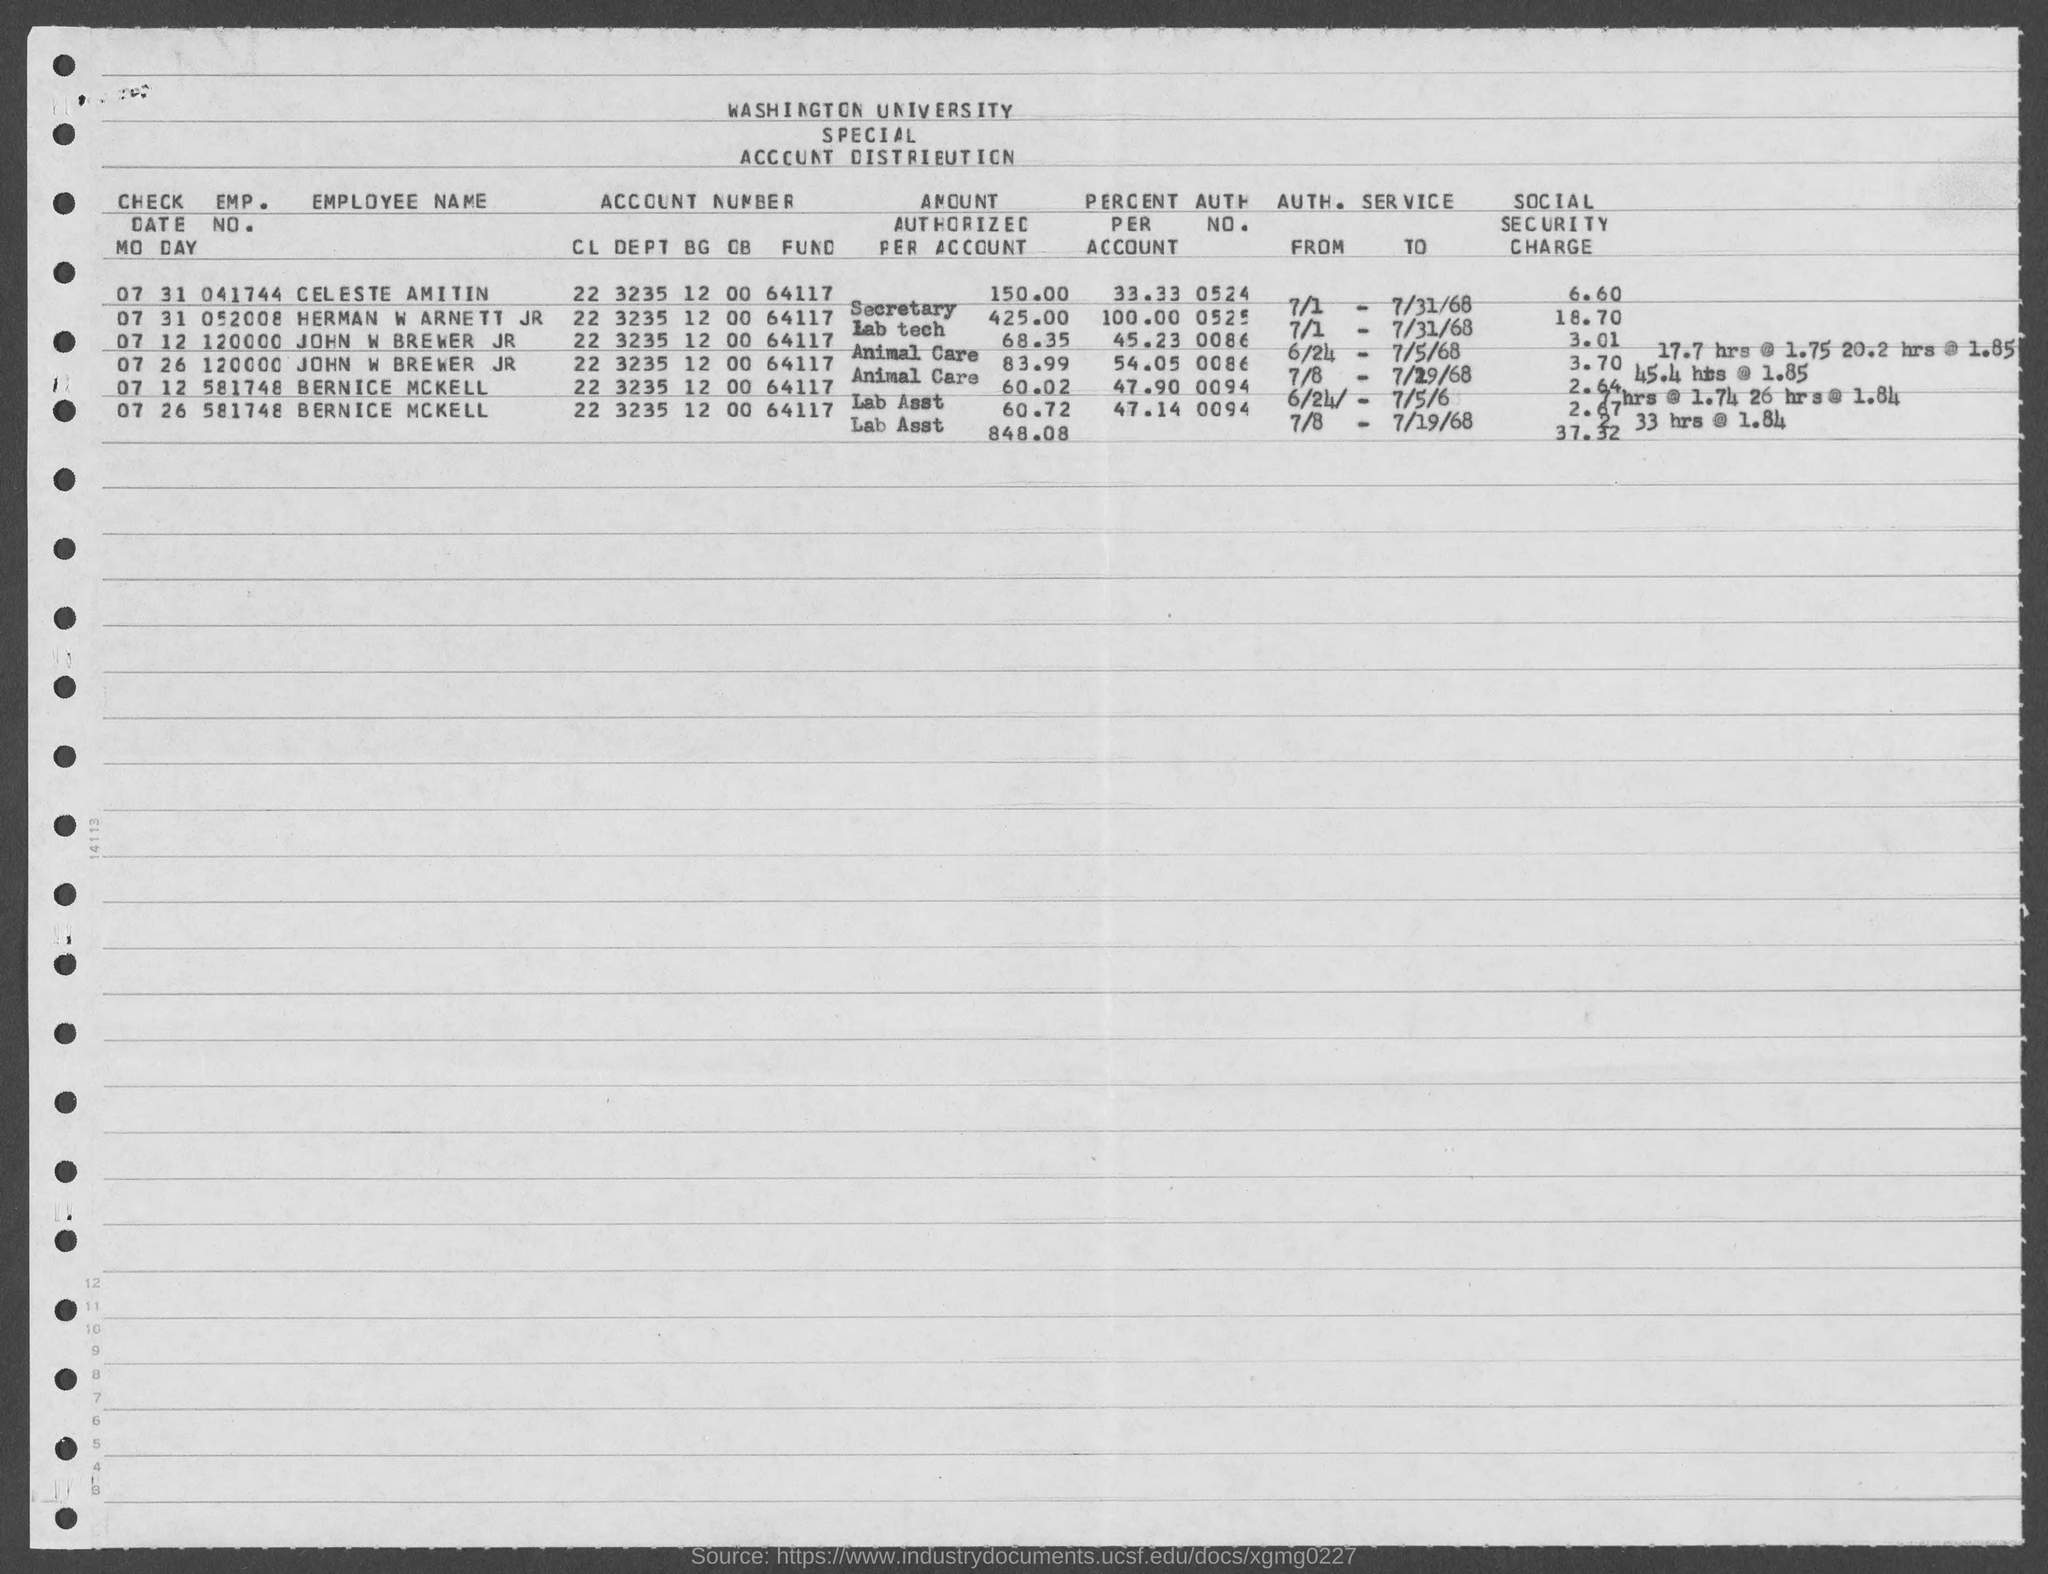Point out several critical features in this image. The emp. no. of Bernice McKell mentioned in the given form is 581748... The emp. no. of Herman W Arnett Jr is 052008. The emp. no. of Celeste Amitin is 041744... The employment number of John W Brewer JR, as mentioned on the given page, is 120000. 